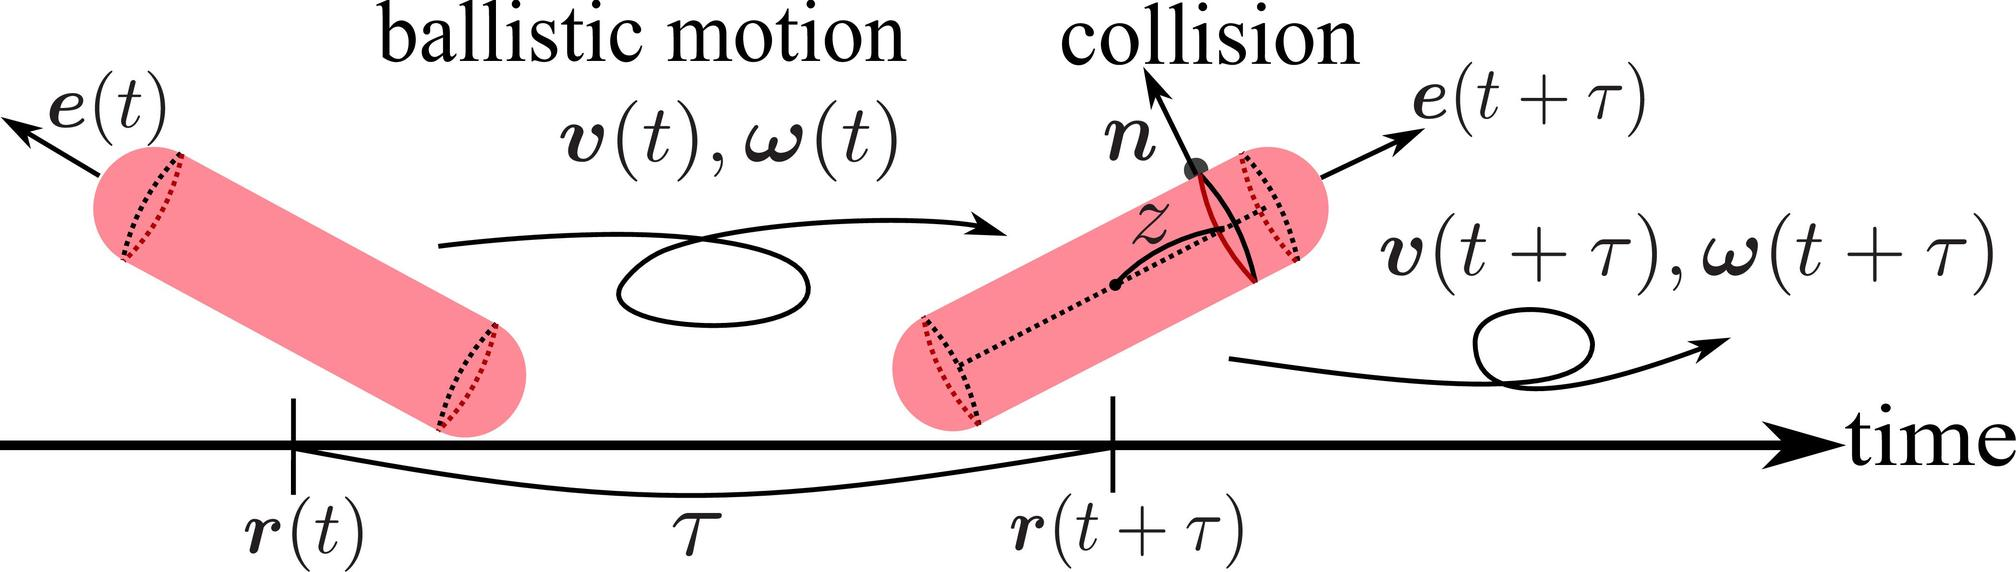Based on the figure, which vector represents the change in orientation of the cylinder as a result of the collision? A. r(t + 	au) - r(t) B. e(t + 	au) - e(t) C. v(t + 	au) - v(t) D. (t + 	au) - (t) In the provided diagram, e(t) designates the orientation of the cylinder at a specific time t, while e(t + 	au) represents the orientation after the time interval 	au, post-collision. The vector difference e(t + 	au) - e(t) effectively captures the alteration in orientation due to the collision. This makes option B the correct answer. This understanding is crucial for analyzing dynamic interactions in physics where orientation changes are critical, such as in the study of rotating bodies or angular momentum conservation. 